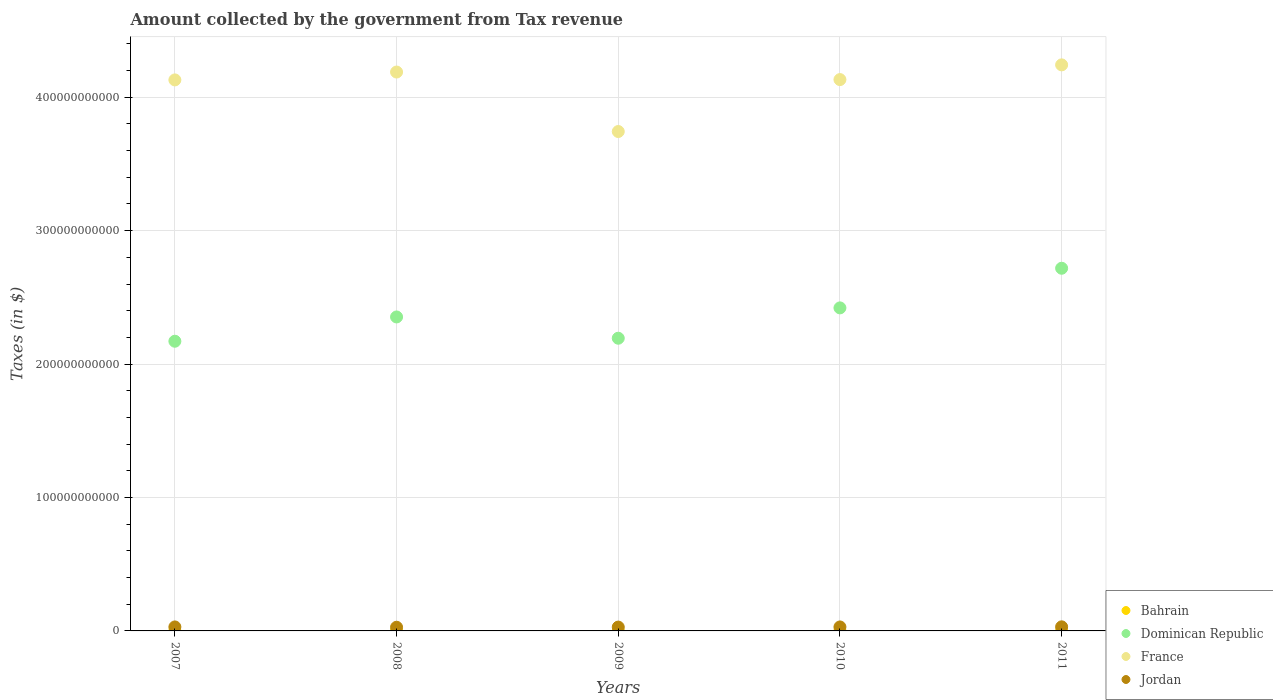How many different coloured dotlines are there?
Provide a succinct answer. 4. What is the amount collected by the government from tax revenue in Dominican Republic in 2009?
Your response must be concise. 2.19e+11. Across all years, what is the maximum amount collected by the government from tax revenue in Bahrain?
Your answer should be compact. 1.21e+08. Across all years, what is the minimum amount collected by the government from tax revenue in Bahrain?
Ensure brevity in your answer.  9.36e+07. In which year was the amount collected by the government from tax revenue in France minimum?
Make the answer very short. 2009. What is the total amount collected by the government from tax revenue in Bahrain in the graph?
Your response must be concise. 5.65e+08. What is the difference between the amount collected by the government from tax revenue in Jordan in 2009 and that in 2010?
Keep it short and to the point. -1.06e+08. What is the difference between the amount collected by the government from tax revenue in Jordan in 2008 and the amount collected by the government from tax revenue in Bahrain in 2009?
Keep it short and to the point. 2.64e+09. What is the average amount collected by the government from tax revenue in Jordan per year?
Make the answer very short. 2.94e+09. In the year 2009, what is the difference between the amount collected by the government from tax revenue in Bahrain and amount collected by the government from tax revenue in Dominican Republic?
Your answer should be very brief. -2.19e+11. In how many years, is the amount collected by the government from tax revenue in Jordan greater than 280000000000 $?
Your response must be concise. 0. What is the ratio of the amount collected by the government from tax revenue in France in 2007 to that in 2008?
Ensure brevity in your answer.  0.99. Is the amount collected by the government from tax revenue in France in 2008 less than that in 2011?
Ensure brevity in your answer.  Yes. What is the difference between the highest and the second highest amount collected by the government from tax revenue in Jordan?
Offer a terse response. 6.70e+07. What is the difference between the highest and the lowest amount collected by the government from tax revenue in Bahrain?
Provide a short and direct response. 2.70e+07. In how many years, is the amount collected by the government from tax revenue in Bahrain greater than the average amount collected by the government from tax revenue in Bahrain taken over all years?
Provide a short and direct response. 4. Is the sum of the amount collected by the government from tax revenue in Dominican Republic in 2008 and 2009 greater than the maximum amount collected by the government from tax revenue in France across all years?
Provide a short and direct response. Yes. Does the amount collected by the government from tax revenue in France monotonically increase over the years?
Your answer should be compact. No. Is the amount collected by the government from tax revenue in Dominican Republic strictly less than the amount collected by the government from tax revenue in Bahrain over the years?
Your answer should be compact. No. How many years are there in the graph?
Make the answer very short. 5. What is the difference between two consecutive major ticks on the Y-axis?
Offer a very short reply. 1.00e+11. Does the graph contain any zero values?
Your response must be concise. No. Does the graph contain grids?
Your answer should be compact. Yes. What is the title of the graph?
Ensure brevity in your answer.  Amount collected by the government from Tax revenue. Does "Guinea" appear as one of the legend labels in the graph?
Your answer should be compact. No. What is the label or title of the Y-axis?
Your answer should be compact. Taxes (in $). What is the Taxes (in $) in Bahrain in 2007?
Keep it short and to the point. 9.36e+07. What is the Taxes (in $) of Dominican Republic in 2007?
Offer a terse response. 2.17e+11. What is the Taxes (in $) in France in 2007?
Provide a succinct answer. 4.13e+11. What is the Taxes (in $) of Jordan in 2007?
Your answer should be very brief. 3.00e+09. What is the Taxes (in $) of Bahrain in 2008?
Provide a short and direct response. 1.19e+08. What is the Taxes (in $) in Dominican Republic in 2008?
Keep it short and to the point. 2.35e+11. What is the Taxes (in $) of France in 2008?
Offer a very short reply. 4.19e+11. What is the Taxes (in $) of Jordan in 2008?
Your answer should be very brief. 2.76e+09. What is the Taxes (in $) of Bahrain in 2009?
Keep it short and to the point. 1.18e+08. What is the Taxes (in $) of Dominican Republic in 2009?
Your answer should be compact. 2.19e+11. What is the Taxes (in $) in France in 2009?
Offer a terse response. 3.74e+11. What is the Taxes (in $) of Jordan in 2009?
Your answer should be compact. 2.88e+09. What is the Taxes (in $) in Bahrain in 2010?
Provide a succinct answer. 1.14e+08. What is the Taxes (in $) in Dominican Republic in 2010?
Offer a terse response. 2.42e+11. What is the Taxes (in $) of France in 2010?
Offer a terse response. 4.13e+11. What is the Taxes (in $) in Jordan in 2010?
Provide a succinct answer. 2.99e+09. What is the Taxes (in $) in Bahrain in 2011?
Provide a short and direct response. 1.21e+08. What is the Taxes (in $) of Dominican Republic in 2011?
Your answer should be very brief. 2.72e+11. What is the Taxes (in $) of France in 2011?
Offer a terse response. 4.24e+11. What is the Taxes (in $) in Jordan in 2011?
Make the answer very short. 3.06e+09. Across all years, what is the maximum Taxes (in $) in Bahrain?
Your response must be concise. 1.21e+08. Across all years, what is the maximum Taxes (in $) of Dominican Republic?
Offer a terse response. 2.72e+11. Across all years, what is the maximum Taxes (in $) in France?
Offer a very short reply. 4.24e+11. Across all years, what is the maximum Taxes (in $) of Jordan?
Your answer should be compact. 3.06e+09. Across all years, what is the minimum Taxes (in $) of Bahrain?
Make the answer very short. 9.36e+07. Across all years, what is the minimum Taxes (in $) of Dominican Republic?
Ensure brevity in your answer.  2.17e+11. Across all years, what is the minimum Taxes (in $) of France?
Offer a terse response. 3.74e+11. Across all years, what is the minimum Taxes (in $) in Jordan?
Offer a very short reply. 2.76e+09. What is the total Taxes (in $) in Bahrain in the graph?
Keep it short and to the point. 5.65e+08. What is the total Taxes (in $) of Dominican Republic in the graph?
Offer a very short reply. 1.19e+12. What is the total Taxes (in $) of France in the graph?
Your answer should be very brief. 2.04e+12. What is the total Taxes (in $) in Jordan in the graph?
Keep it short and to the point. 1.47e+1. What is the difference between the Taxes (in $) of Bahrain in 2007 and that in 2008?
Ensure brevity in your answer.  -2.59e+07. What is the difference between the Taxes (in $) in Dominican Republic in 2007 and that in 2008?
Provide a succinct answer. -1.82e+1. What is the difference between the Taxes (in $) in France in 2007 and that in 2008?
Make the answer very short. -5.90e+09. What is the difference between the Taxes (in $) of Jordan in 2007 and that in 2008?
Your answer should be compact. 2.37e+08. What is the difference between the Taxes (in $) in Bahrain in 2007 and that in 2009?
Offer a terse response. -2.40e+07. What is the difference between the Taxes (in $) in Dominican Republic in 2007 and that in 2009?
Your response must be concise. -2.26e+09. What is the difference between the Taxes (in $) in France in 2007 and that in 2009?
Your answer should be compact. 3.87e+1. What is the difference between the Taxes (in $) of Jordan in 2007 and that in 2009?
Give a very brief answer. 1.15e+08. What is the difference between the Taxes (in $) of Bahrain in 2007 and that in 2010?
Your response must be concise. -2.02e+07. What is the difference between the Taxes (in $) in Dominican Republic in 2007 and that in 2010?
Give a very brief answer. -2.50e+1. What is the difference between the Taxes (in $) of France in 2007 and that in 2010?
Ensure brevity in your answer.  -2.44e+08. What is the difference between the Taxes (in $) of Jordan in 2007 and that in 2010?
Offer a terse response. 9.30e+06. What is the difference between the Taxes (in $) of Bahrain in 2007 and that in 2011?
Ensure brevity in your answer.  -2.70e+07. What is the difference between the Taxes (in $) in Dominican Republic in 2007 and that in 2011?
Offer a terse response. -5.47e+1. What is the difference between the Taxes (in $) in France in 2007 and that in 2011?
Make the answer very short. -1.13e+1. What is the difference between the Taxes (in $) of Jordan in 2007 and that in 2011?
Your response must be concise. -6.70e+07. What is the difference between the Taxes (in $) of Bahrain in 2008 and that in 2009?
Offer a terse response. 1.90e+06. What is the difference between the Taxes (in $) in Dominican Republic in 2008 and that in 2009?
Offer a very short reply. 1.59e+1. What is the difference between the Taxes (in $) of France in 2008 and that in 2009?
Provide a succinct answer. 4.46e+1. What is the difference between the Taxes (in $) in Jordan in 2008 and that in 2009?
Your answer should be very brief. -1.22e+08. What is the difference between the Taxes (in $) of Bahrain in 2008 and that in 2010?
Your response must be concise. 5.75e+06. What is the difference between the Taxes (in $) of Dominican Republic in 2008 and that in 2010?
Ensure brevity in your answer.  -6.79e+09. What is the difference between the Taxes (in $) in France in 2008 and that in 2010?
Ensure brevity in your answer.  5.66e+09. What is the difference between the Taxes (in $) of Jordan in 2008 and that in 2010?
Keep it short and to the point. -2.28e+08. What is the difference between the Taxes (in $) in Bahrain in 2008 and that in 2011?
Your answer should be very brief. -1.08e+06. What is the difference between the Taxes (in $) of Dominican Republic in 2008 and that in 2011?
Your answer should be compact. -3.65e+1. What is the difference between the Taxes (in $) of France in 2008 and that in 2011?
Offer a terse response. -5.37e+09. What is the difference between the Taxes (in $) in Jordan in 2008 and that in 2011?
Ensure brevity in your answer.  -3.04e+08. What is the difference between the Taxes (in $) of Bahrain in 2009 and that in 2010?
Your response must be concise. 3.85e+06. What is the difference between the Taxes (in $) of Dominican Republic in 2009 and that in 2010?
Provide a short and direct response. -2.27e+1. What is the difference between the Taxes (in $) of France in 2009 and that in 2010?
Make the answer very short. -3.89e+1. What is the difference between the Taxes (in $) of Jordan in 2009 and that in 2010?
Provide a short and direct response. -1.06e+08. What is the difference between the Taxes (in $) in Bahrain in 2009 and that in 2011?
Provide a short and direct response. -2.98e+06. What is the difference between the Taxes (in $) of Dominican Republic in 2009 and that in 2011?
Your answer should be compact. -5.24e+1. What is the difference between the Taxes (in $) in France in 2009 and that in 2011?
Provide a succinct answer. -5.00e+1. What is the difference between the Taxes (in $) of Jordan in 2009 and that in 2011?
Your response must be concise. -1.82e+08. What is the difference between the Taxes (in $) of Bahrain in 2010 and that in 2011?
Offer a very short reply. -6.83e+06. What is the difference between the Taxes (in $) in Dominican Republic in 2010 and that in 2011?
Offer a terse response. -2.97e+1. What is the difference between the Taxes (in $) of France in 2010 and that in 2011?
Offer a terse response. -1.10e+1. What is the difference between the Taxes (in $) of Jordan in 2010 and that in 2011?
Offer a very short reply. -7.63e+07. What is the difference between the Taxes (in $) of Bahrain in 2007 and the Taxes (in $) of Dominican Republic in 2008?
Give a very brief answer. -2.35e+11. What is the difference between the Taxes (in $) in Bahrain in 2007 and the Taxes (in $) in France in 2008?
Your answer should be very brief. -4.19e+11. What is the difference between the Taxes (in $) of Bahrain in 2007 and the Taxes (in $) of Jordan in 2008?
Offer a very short reply. -2.66e+09. What is the difference between the Taxes (in $) in Dominican Republic in 2007 and the Taxes (in $) in France in 2008?
Give a very brief answer. -2.02e+11. What is the difference between the Taxes (in $) of Dominican Republic in 2007 and the Taxes (in $) of Jordan in 2008?
Offer a terse response. 2.14e+11. What is the difference between the Taxes (in $) of France in 2007 and the Taxes (in $) of Jordan in 2008?
Offer a very short reply. 4.10e+11. What is the difference between the Taxes (in $) in Bahrain in 2007 and the Taxes (in $) in Dominican Republic in 2009?
Provide a succinct answer. -2.19e+11. What is the difference between the Taxes (in $) in Bahrain in 2007 and the Taxes (in $) in France in 2009?
Your response must be concise. -3.74e+11. What is the difference between the Taxes (in $) in Bahrain in 2007 and the Taxes (in $) in Jordan in 2009?
Keep it short and to the point. -2.79e+09. What is the difference between the Taxes (in $) in Dominican Republic in 2007 and the Taxes (in $) in France in 2009?
Provide a short and direct response. -1.57e+11. What is the difference between the Taxes (in $) of Dominican Republic in 2007 and the Taxes (in $) of Jordan in 2009?
Ensure brevity in your answer.  2.14e+11. What is the difference between the Taxes (in $) of France in 2007 and the Taxes (in $) of Jordan in 2009?
Offer a terse response. 4.10e+11. What is the difference between the Taxes (in $) in Bahrain in 2007 and the Taxes (in $) in Dominican Republic in 2010?
Give a very brief answer. -2.42e+11. What is the difference between the Taxes (in $) of Bahrain in 2007 and the Taxes (in $) of France in 2010?
Your response must be concise. -4.13e+11. What is the difference between the Taxes (in $) in Bahrain in 2007 and the Taxes (in $) in Jordan in 2010?
Provide a succinct answer. -2.89e+09. What is the difference between the Taxes (in $) of Dominican Republic in 2007 and the Taxes (in $) of France in 2010?
Keep it short and to the point. -1.96e+11. What is the difference between the Taxes (in $) of Dominican Republic in 2007 and the Taxes (in $) of Jordan in 2010?
Keep it short and to the point. 2.14e+11. What is the difference between the Taxes (in $) of France in 2007 and the Taxes (in $) of Jordan in 2010?
Your answer should be compact. 4.10e+11. What is the difference between the Taxes (in $) in Bahrain in 2007 and the Taxes (in $) in Dominican Republic in 2011?
Offer a terse response. -2.72e+11. What is the difference between the Taxes (in $) of Bahrain in 2007 and the Taxes (in $) of France in 2011?
Your answer should be very brief. -4.24e+11. What is the difference between the Taxes (in $) of Bahrain in 2007 and the Taxes (in $) of Jordan in 2011?
Ensure brevity in your answer.  -2.97e+09. What is the difference between the Taxes (in $) in Dominican Republic in 2007 and the Taxes (in $) in France in 2011?
Offer a terse response. -2.07e+11. What is the difference between the Taxes (in $) in Dominican Republic in 2007 and the Taxes (in $) in Jordan in 2011?
Provide a short and direct response. 2.14e+11. What is the difference between the Taxes (in $) in France in 2007 and the Taxes (in $) in Jordan in 2011?
Your response must be concise. 4.10e+11. What is the difference between the Taxes (in $) in Bahrain in 2008 and the Taxes (in $) in Dominican Republic in 2009?
Ensure brevity in your answer.  -2.19e+11. What is the difference between the Taxes (in $) in Bahrain in 2008 and the Taxes (in $) in France in 2009?
Keep it short and to the point. -3.74e+11. What is the difference between the Taxes (in $) in Bahrain in 2008 and the Taxes (in $) in Jordan in 2009?
Keep it short and to the point. -2.76e+09. What is the difference between the Taxes (in $) in Dominican Republic in 2008 and the Taxes (in $) in France in 2009?
Ensure brevity in your answer.  -1.39e+11. What is the difference between the Taxes (in $) in Dominican Republic in 2008 and the Taxes (in $) in Jordan in 2009?
Ensure brevity in your answer.  2.32e+11. What is the difference between the Taxes (in $) of France in 2008 and the Taxes (in $) of Jordan in 2009?
Your response must be concise. 4.16e+11. What is the difference between the Taxes (in $) of Bahrain in 2008 and the Taxes (in $) of Dominican Republic in 2010?
Your answer should be very brief. -2.42e+11. What is the difference between the Taxes (in $) of Bahrain in 2008 and the Taxes (in $) of France in 2010?
Your answer should be compact. -4.13e+11. What is the difference between the Taxes (in $) in Bahrain in 2008 and the Taxes (in $) in Jordan in 2010?
Make the answer very short. -2.87e+09. What is the difference between the Taxes (in $) in Dominican Republic in 2008 and the Taxes (in $) in France in 2010?
Ensure brevity in your answer.  -1.78e+11. What is the difference between the Taxes (in $) in Dominican Republic in 2008 and the Taxes (in $) in Jordan in 2010?
Offer a terse response. 2.32e+11. What is the difference between the Taxes (in $) in France in 2008 and the Taxes (in $) in Jordan in 2010?
Keep it short and to the point. 4.16e+11. What is the difference between the Taxes (in $) in Bahrain in 2008 and the Taxes (in $) in Dominican Republic in 2011?
Ensure brevity in your answer.  -2.72e+11. What is the difference between the Taxes (in $) of Bahrain in 2008 and the Taxes (in $) of France in 2011?
Ensure brevity in your answer.  -4.24e+11. What is the difference between the Taxes (in $) in Bahrain in 2008 and the Taxes (in $) in Jordan in 2011?
Ensure brevity in your answer.  -2.94e+09. What is the difference between the Taxes (in $) of Dominican Republic in 2008 and the Taxes (in $) of France in 2011?
Your answer should be compact. -1.89e+11. What is the difference between the Taxes (in $) in Dominican Republic in 2008 and the Taxes (in $) in Jordan in 2011?
Your answer should be very brief. 2.32e+11. What is the difference between the Taxes (in $) of France in 2008 and the Taxes (in $) of Jordan in 2011?
Offer a terse response. 4.16e+11. What is the difference between the Taxes (in $) of Bahrain in 2009 and the Taxes (in $) of Dominican Republic in 2010?
Provide a succinct answer. -2.42e+11. What is the difference between the Taxes (in $) of Bahrain in 2009 and the Taxes (in $) of France in 2010?
Your response must be concise. -4.13e+11. What is the difference between the Taxes (in $) of Bahrain in 2009 and the Taxes (in $) of Jordan in 2010?
Make the answer very short. -2.87e+09. What is the difference between the Taxes (in $) of Dominican Republic in 2009 and the Taxes (in $) of France in 2010?
Your answer should be compact. -1.94e+11. What is the difference between the Taxes (in $) of Dominican Republic in 2009 and the Taxes (in $) of Jordan in 2010?
Ensure brevity in your answer.  2.16e+11. What is the difference between the Taxes (in $) of France in 2009 and the Taxes (in $) of Jordan in 2010?
Offer a terse response. 3.71e+11. What is the difference between the Taxes (in $) in Bahrain in 2009 and the Taxes (in $) in Dominican Republic in 2011?
Provide a succinct answer. -2.72e+11. What is the difference between the Taxes (in $) of Bahrain in 2009 and the Taxes (in $) of France in 2011?
Keep it short and to the point. -4.24e+11. What is the difference between the Taxes (in $) in Bahrain in 2009 and the Taxes (in $) in Jordan in 2011?
Your answer should be very brief. -2.94e+09. What is the difference between the Taxes (in $) of Dominican Republic in 2009 and the Taxes (in $) of France in 2011?
Keep it short and to the point. -2.05e+11. What is the difference between the Taxes (in $) of Dominican Republic in 2009 and the Taxes (in $) of Jordan in 2011?
Ensure brevity in your answer.  2.16e+11. What is the difference between the Taxes (in $) of France in 2009 and the Taxes (in $) of Jordan in 2011?
Give a very brief answer. 3.71e+11. What is the difference between the Taxes (in $) of Bahrain in 2010 and the Taxes (in $) of Dominican Republic in 2011?
Your answer should be very brief. -2.72e+11. What is the difference between the Taxes (in $) in Bahrain in 2010 and the Taxes (in $) in France in 2011?
Keep it short and to the point. -4.24e+11. What is the difference between the Taxes (in $) in Bahrain in 2010 and the Taxes (in $) in Jordan in 2011?
Your answer should be very brief. -2.95e+09. What is the difference between the Taxes (in $) in Dominican Republic in 2010 and the Taxes (in $) in France in 2011?
Your answer should be compact. -1.82e+11. What is the difference between the Taxes (in $) of Dominican Republic in 2010 and the Taxes (in $) of Jordan in 2011?
Give a very brief answer. 2.39e+11. What is the difference between the Taxes (in $) of France in 2010 and the Taxes (in $) of Jordan in 2011?
Ensure brevity in your answer.  4.10e+11. What is the average Taxes (in $) of Bahrain per year?
Your response must be concise. 1.13e+08. What is the average Taxes (in $) in Dominican Republic per year?
Offer a terse response. 2.37e+11. What is the average Taxes (in $) of France per year?
Your answer should be compact. 4.09e+11. What is the average Taxes (in $) of Jordan per year?
Offer a very short reply. 2.94e+09. In the year 2007, what is the difference between the Taxes (in $) in Bahrain and Taxes (in $) in Dominican Republic?
Ensure brevity in your answer.  -2.17e+11. In the year 2007, what is the difference between the Taxes (in $) of Bahrain and Taxes (in $) of France?
Ensure brevity in your answer.  -4.13e+11. In the year 2007, what is the difference between the Taxes (in $) of Bahrain and Taxes (in $) of Jordan?
Provide a succinct answer. -2.90e+09. In the year 2007, what is the difference between the Taxes (in $) in Dominican Republic and Taxes (in $) in France?
Offer a very short reply. -1.96e+11. In the year 2007, what is the difference between the Taxes (in $) in Dominican Republic and Taxes (in $) in Jordan?
Make the answer very short. 2.14e+11. In the year 2007, what is the difference between the Taxes (in $) of France and Taxes (in $) of Jordan?
Offer a very short reply. 4.10e+11. In the year 2008, what is the difference between the Taxes (in $) in Bahrain and Taxes (in $) in Dominican Republic?
Ensure brevity in your answer.  -2.35e+11. In the year 2008, what is the difference between the Taxes (in $) of Bahrain and Taxes (in $) of France?
Make the answer very short. -4.19e+11. In the year 2008, what is the difference between the Taxes (in $) of Bahrain and Taxes (in $) of Jordan?
Ensure brevity in your answer.  -2.64e+09. In the year 2008, what is the difference between the Taxes (in $) in Dominican Republic and Taxes (in $) in France?
Your response must be concise. -1.84e+11. In the year 2008, what is the difference between the Taxes (in $) of Dominican Republic and Taxes (in $) of Jordan?
Your answer should be compact. 2.33e+11. In the year 2008, what is the difference between the Taxes (in $) in France and Taxes (in $) in Jordan?
Offer a terse response. 4.16e+11. In the year 2009, what is the difference between the Taxes (in $) in Bahrain and Taxes (in $) in Dominican Republic?
Ensure brevity in your answer.  -2.19e+11. In the year 2009, what is the difference between the Taxes (in $) in Bahrain and Taxes (in $) in France?
Give a very brief answer. -3.74e+11. In the year 2009, what is the difference between the Taxes (in $) of Bahrain and Taxes (in $) of Jordan?
Offer a terse response. -2.76e+09. In the year 2009, what is the difference between the Taxes (in $) in Dominican Republic and Taxes (in $) in France?
Provide a succinct answer. -1.55e+11. In the year 2009, what is the difference between the Taxes (in $) of Dominican Republic and Taxes (in $) of Jordan?
Your answer should be very brief. 2.16e+11. In the year 2009, what is the difference between the Taxes (in $) in France and Taxes (in $) in Jordan?
Ensure brevity in your answer.  3.71e+11. In the year 2010, what is the difference between the Taxes (in $) in Bahrain and Taxes (in $) in Dominican Republic?
Your answer should be compact. -2.42e+11. In the year 2010, what is the difference between the Taxes (in $) of Bahrain and Taxes (in $) of France?
Give a very brief answer. -4.13e+11. In the year 2010, what is the difference between the Taxes (in $) of Bahrain and Taxes (in $) of Jordan?
Make the answer very short. -2.87e+09. In the year 2010, what is the difference between the Taxes (in $) of Dominican Republic and Taxes (in $) of France?
Your response must be concise. -1.71e+11. In the year 2010, what is the difference between the Taxes (in $) of Dominican Republic and Taxes (in $) of Jordan?
Provide a succinct answer. 2.39e+11. In the year 2010, what is the difference between the Taxes (in $) of France and Taxes (in $) of Jordan?
Your response must be concise. 4.10e+11. In the year 2011, what is the difference between the Taxes (in $) in Bahrain and Taxes (in $) in Dominican Republic?
Your answer should be very brief. -2.72e+11. In the year 2011, what is the difference between the Taxes (in $) in Bahrain and Taxes (in $) in France?
Keep it short and to the point. -4.24e+11. In the year 2011, what is the difference between the Taxes (in $) of Bahrain and Taxes (in $) of Jordan?
Ensure brevity in your answer.  -2.94e+09. In the year 2011, what is the difference between the Taxes (in $) of Dominican Republic and Taxes (in $) of France?
Your answer should be very brief. -1.52e+11. In the year 2011, what is the difference between the Taxes (in $) of Dominican Republic and Taxes (in $) of Jordan?
Provide a short and direct response. 2.69e+11. In the year 2011, what is the difference between the Taxes (in $) of France and Taxes (in $) of Jordan?
Provide a short and direct response. 4.21e+11. What is the ratio of the Taxes (in $) of Bahrain in 2007 to that in 2008?
Keep it short and to the point. 0.78. What is the ratio of the Taxes (in $) of Dominican Republic in 2007 to that in 2008?
Keep it short and to the point. 0.92. What is the ratio of the Taxes (in $) of France in 2007 to that in 2008?
Offer a very short reply. 0.99. What is the ratio of the Taxes (in $) of Jordan in 2007 to that in 2008?
Your answer should be compact. 1.09. What is the ratio of the Taxes (in $) of Bahrain in 2007 to that in 2009?
Your response must be concise. 0.8. What is the ratio of the Taxes (in $) in France in 2007 to that in 2009?
Your response must be concise. 1.1. What is the ratio of the Taxes (in $) in Bahrain in 2007 to that in 2010?
Your answer should be compact. 0.82. What is the ratio of the Taxes (in $) in Dominican Republic in 2007 to that in 2010?
Give a very brief answer. 0.9. What is the ratio of the Taxes (in $) of Jordan in 2007 to that in 2010?
Make the answer very short. 1. What is the ratio of the Taxes (in $) in Bahrain in 2007 to that in 2011?
Give a very brief answer. 0.78. What is the ratio of the Taxes (in $) in Dominican Republic in 2007 to that in 2011?
Give a very brief answer. 0.8. What is the ratio of the Taxes (in $) of France in 2007 to that in 2011?
Give a very brief answer. 0.97. What is the ratio of the Taxes (in $) in Jordan in 2007 to that in 2011?
Offer a very short reply. 0.98. What is the ratio of the Taxes (in $) in Bahrain in 2008 to that in 2009?
Make the answer very short. 1.02. What is the ratio of the Taxes (in $) in Dominican Republic in 2008 to that in 2009?
Ensure brevity in your answer.  1.07. What is the ratio of the Taxes (in $) of France in 2008 to that in 2009?
Offer a very short reply. 1.12. What is the ratio of the Taxes (in $) in Jordan in 2008 to that in 2009?
Your response must be concise. 0.96. What is the ratio of the Taxes (in $) in Bahrain in 2008 to that in 2010?
Your response must be concise. 1.05. What is the ratio of the Taxes (in $) in Dominican Republic in 2008 to that in 2010?
Make the answer very short. 0.97. What is the ratio of the Taxes (in $) in France in 2008 to that in 2010?
Ensure brevity in your answer.  1.01. What is the ratio of the Taxes (in $) of Jordan in 2008 to that in 2010?
Ensure brevity in your answer.  0.92. What is the ratio of the Taxes (in $) in Bahrain in 2008 to that in 2011?
Ensure brevity in your answer.  0.99. What is the ratio of the Taxes (in $) in Dominican Republic in 2008 to that in 2011?
Ensure brevity in your answer.  0.87. What is the ratio of the Taxes (in $) in France in 2008 to that in 2011?
Your response must be concise. 0.99. What is the ratio of the Taxes (in $) in Jordan in 2008 to that in 2011?
Provide a short and direct response. 0.9. What is the ratio of the Taxes (in $) of Bahrain in 2009 to that in 2010?
Provide a succinct answer. 1.03. What is the ratio of the Taxes (in $) of Dominican Republic in 2009 to that in 2010?
Offer a very short reply. 0.91. What is the ratio of the Taxes (in $) of France in 2009 to that in 2010?
Offer a very short reply. 0.91. What is the ratio of the Taxes (in $) of Jordan in 2009 to that in 2010?
Provide a short and direct response. 0.96. What is the ratio of the Taxes (in $) in Bahrain in 2009 to that in 2011?
Keep it short and to the point. 0.98. What is the ratio of the Taxes (in $) of Dominican Republic in 2009 to that in 2011?
Your response must be concise. 0.81. What is the ratio of the Taxes (in $) in France in 2009 to that in 2011?
Your response must be concise. 0.88. What is the ratio of the Taxes (in $) in Jordan in 2009 to that in 2011?
Provide a succinct answer. 0.94. What is the ratio of the Taxes (in $) of Bahrain in 2010 to that in 2011?
Your answer should be very brief. 0.94. What is the ratio of the Taxes (in $) of Dominican Republic in 2010 to that in 2011?
Make the answer very short. 0.89. What is the ratio of the Taxes (in $) in Jordan in 2010 to that in 2011?
Provide a short and direct response. 0.98. What is the difference between the highest and the second highest Taxes (in $) in Bahrain?
Your response must be concise. 1.08e+06. What is the difference between the highest and the second highest Taxes (in $) of Dominican Republic?
Offer a terse response. 2.97e+1. What is the difference between the highest and the second highest Taxes (in $) of France?
Your answer should be very brief. 5.37e+09. What is the difference between the highest and the second highest Taxes (in $) of Jordan?
Offer a very short reply. 6.70e+07. What is the difference between the highest and the lowest Taxes (in $) in Bahrain?
Provide a short and direct response. 2.70e+07. What is the difference between the highest and the lowest Taxes (in $) of Dominican Republic?
Offer a terse response. 5.47e+1. What is the difference between the highest and the lowest Taxes (in $) of France?
Your response must be concise. 5.00e+1. What is the difference between the highest and the lowest Taxes (in $) of Jordan?
Offer a terse response. 3.04e+08. 